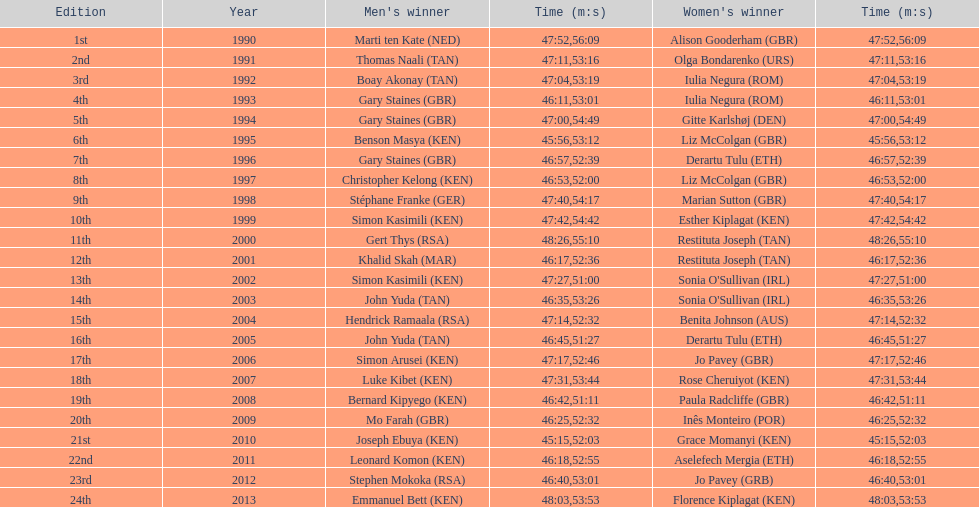The additional female champion with an identical completion time as jo pavey in 201 Iulia Negura. 